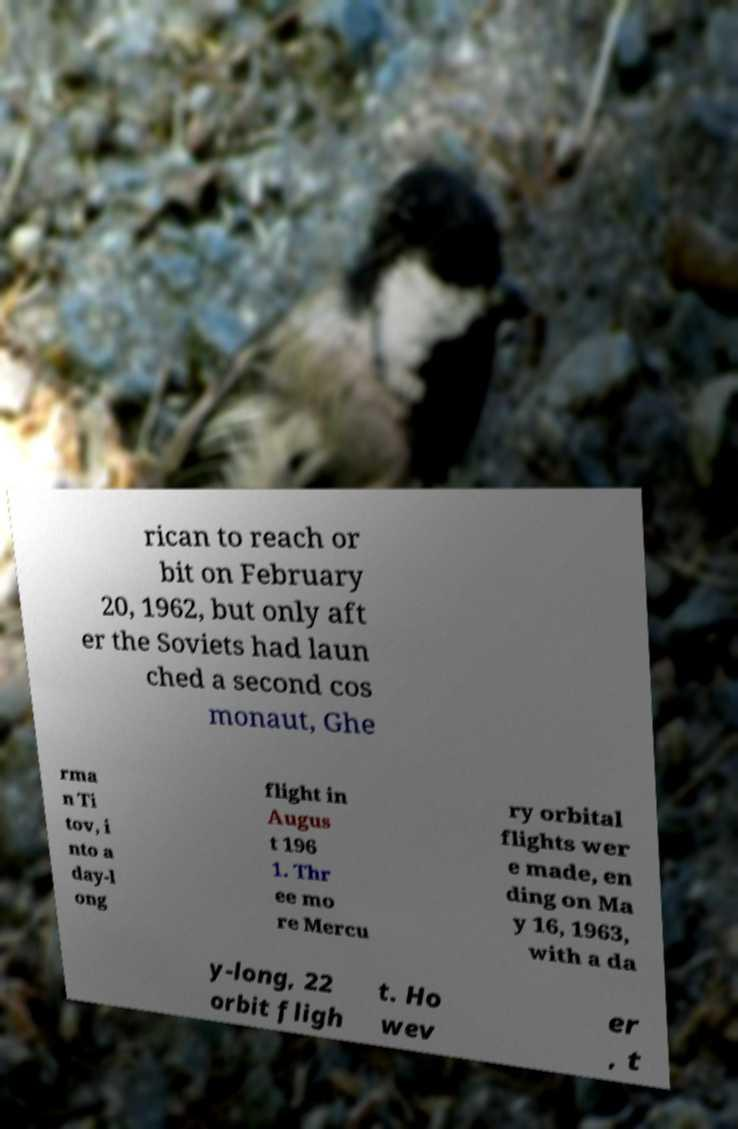Can you accurately transcribe the text from the provided image for me? rican to reach or bit on February 20, 1962, but only aft er the Soviets had laun ched a second cos monaut, Ghe rma n Ti tov, i nto a day-l ong flight in Augus t 196 1. Thr ee mo re Mercu ry orbital flights wer e made, en ding on Ma y 16, 1963, with a da y-long, 22 orbit fligh t. Ho wev er , t 